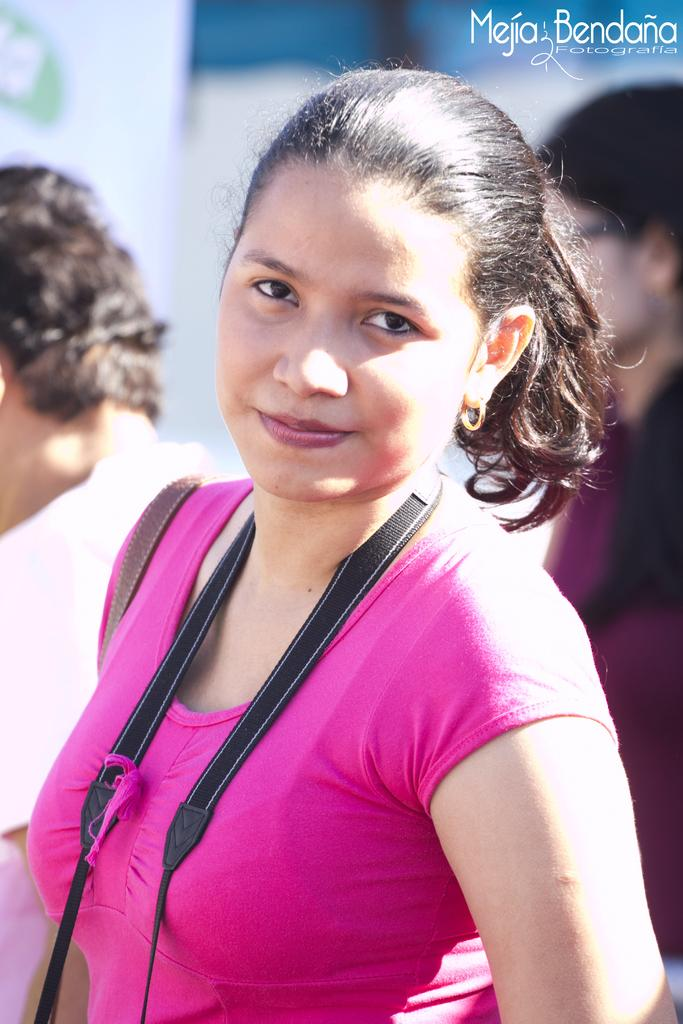Who is the main subject in the image? There is a woman in the middle of the image. Can you describe the background of the image? There are two people in the background of the image. Is there any additional information or branding present in the image? Yes, there is a watermark at the top of the image. What type of wing is visible on the woman in the image? There is no wing visible on the woman in the image. What invention is the woman holding in the image? The image does not show the woman holding any invention. 